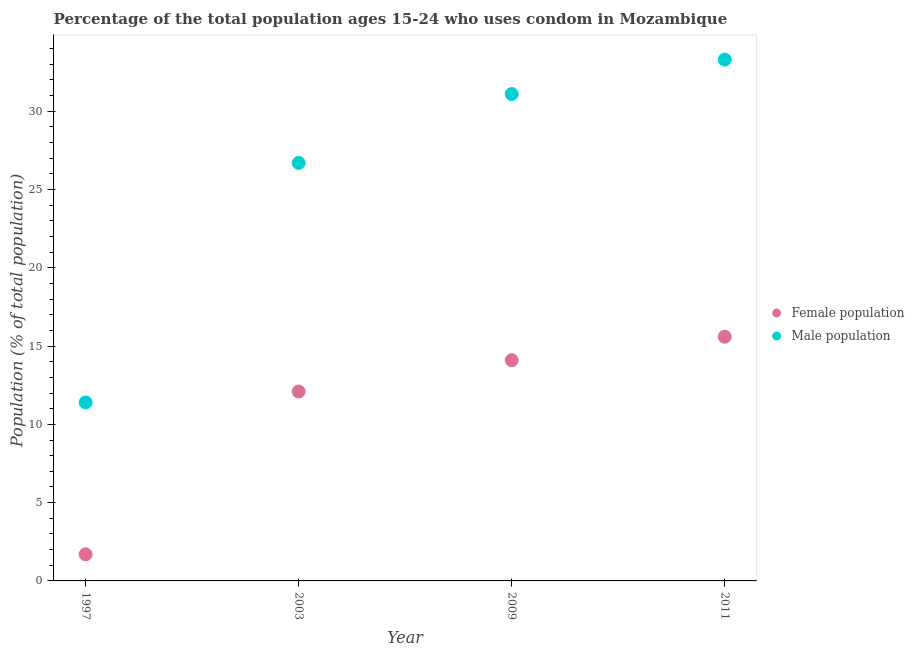What is the male population in 2003?
Give a very brief answer. 26.7. Across all years, what is the maximum male population?
Make the answer very short. 33.3. In which year was the female population maximum?
Provide a succinct answer. 2011. What is the total male population in the graph?
Your answer should be very brief. 102.5. What is the difference between the female population in 2003 and that in 2009?
Offer a very short reply. -2. What is the difference between the female population in 2011 and the male population in 2009?
Provide a succinct answer. -15.5. What is the average male population per year?
Keep it short and to the point. 25.62. In how many years, is the female population greater than 10 %?
Offer a terse response. 3. What is the ratio of the female population in 2003 to that in 2009?
Give a very brief answer. 0.86. Is the difference between the male population in 2003 and 2009 greater than the difference between the female population in 2003 and 2009?
Your answer should be compact. No. What is the difference between the highest and the second highest male population?
Offer a terse response. 2.2. What is the difference between the highest and the lowest male population?
Provide a succinct answer. 21.9. Is the sum of the male population in 1997 and 2011 greater than the maximum female population across all years?
Keep it short and to the point. Yes. How many dotlines are there?
Give a very brief answer. 2. How many years are there in the graph?
Keep it short and to the point. 4. What is the difference between two consecutive major ticks on the Y-axis?
Offer a terse response. 5. Are the values on the major ticks of Y-axis written in scientific E-notation?
Offer a terse response. No. Does the graph contain any zero values?
Provide a short and direct response. No. Does the graph contain grids?
Provide a short and direct response. No. How are the legend labels stacked?
Provide a succinct answer. Vertical. What is the title of the graph?
Ensure brevity in your answer.  Percentage of the total population ages 15-24 who uses condom in Mozambique. What is the label or title of the X-axis?
Keep it short and to the point. Year. What is the label or title of the Y-axis?
Make the answer very short. Population (% of total population) . What is the Population (% of total population)  in Female population in 2003?
Keep it short and to the point. 12.1. What is the Population (% of total population)  in Male population in 2003?
Ensure brevity in your answer.  26.7. What is the Population (% of total population)  of Female population in 2009?
Your answer should be compact. 14.1. What is the Population (% of total population)  of Male population in 2009?
Ensure brevity in your answer.  31.1. What is the Population (% of total population)  of Female population in 2011?
Keep it short and to the point. 15.6. What is the Population (% of total population)  of Male population in 2011?
Your answer should be compact. 33.3. Across all years, what is the maximum Population (% of total population)  of Male population?
Offer a terse response. 33.3. Across all years, what is the minimum Population (% of total population)  of Female population?
Your response must be concise. 1.7. Across all years, what is the minimum Population (% of total population)  of Male population?
Offer a terse response. 11.4. What is the total Population (% of total population)  of Female population in the graph?
Ensure brevity in your answer.  43.5. What is the total Population (% of total population)  of Male population in the graph?
Your answer should be compact. 102.5. What is the difference between the Population (% of total population)  of Male population in 1997 and that in 2003?
Provide a short and direct response. -15.3. What is the difference between the Population (% of total population)  of Male population in 1997 and that in 2009?
Ensure brevity in your answer.  -19.7. What is the difference between the Population (% of total population)  of Male population in 1997 and that in 2011?
Offer a very short reply. -21.9. What is the difference between the Population (% of total population)  of Male population in 2003 and that in 2009?
Offer a very short reply. -4.4. What is the difference between the Population (% of total population)  in Female population in 1997 and the Population (% of total population)  in Male population in 2003?
Your answer should be very brief. -25. What is the difference between the Population (% of total population)  in Female population in 1997 and the Population (% of total population)  in Male population in 2009?
Keep it short and to the point. -29.4. What is the difference between the Population (% of total population)  of Female population in 1997 and the Population (% of total population)  of Male population in 2011?
Provide a short and direct response. -31.6. What is the difference between the Population (% of total population)  in Female population in 2003 and the Population (% of total population)  in Male population in 2009?
Offer a terse response. -19. What is the difference between the Population (% of total population)  in Female population in 2003 and the Population (% of total population)  in Male population in 2011?
Make the answer very short. -21.2. What is the difference between the Population (% of total population)  in Female population in 2009 and the Population (% of total population)  in Male population in 2011?
Give a very brief answer. -19.2. What is the average Population (% of total population)  of Female population per year?
Give a very brief answer. 10.88. What is the average Population (% of total population)  of Male population per year?
Your answer should be compact. 25.62. In the year 2003, what is the difference between the Population (% of total population)  in Female population and Population (% of total population)  in Male population?
Your response must be concise. -14.6. In the year 2009, what is the difference between the Population (% of total population)  in Female population and Population (% of total population)  in Male population?
Provide a succinct answer. -17. In the year 2011, what is the difference between the Population (% of total population)  in Female population and Population (% of total population)  in Male population?
Make the answer very short. -17.7. What is the ratio of the Population (% of total population)  of Female population in 1997 to that in 2003?
Your answer should be very brief. 0.14. What is the ratio of the Population (% of total population)  of Male population in 1997 to that in 2003?
Make the answer very short. 0.43. What is the ratio of the Population (% of total population)  of Female population in 1997 to that in 2009?
Your answer should be compact. 0.12. What is the ratio of the Population (% of total population)  in Male population in 1997 to that in 2009?
Offer a terse response. 0.37. What is the ratio of the Population (% of total population)  in Female population in 1997 to that in 2011?
Offer a very short reply. 0.11. What is the ratio of the Population (% of total population)  in Male population in 1997 to that in 2011?
Your answer should be very brief. 0.34. What is the ratio of the Population (% of total population)  in Female population in 2003 to that in 2009?
Your answer should be compact. 0.86. What is the ratio of the Population (% of total population)  in Male population in 2003 to that in 2009?
Provide a short and direct response. 0.86. What is the ratio of the Population (% of total population)  of Female population in 2003 to that in 2011?
Offer a very short reply. 0.78. What is the ratio of the Population (% of total population)  in Male population in 2003 to that in 2011?
Your answer should be very brief. 0.8. What is the ratio of the Population (% of total population)  of Female population in 2009 to that in 2011?
Provide a succinct answer. 0.9. What is the ratio of the Population (% of total population)  of Male population in 2009 to that in 2011?
Make the answer very short. 0.93. What is the difference between the highest and the second highest Population (% of total population)  in Male population?
Your answer should be compact. 2.2. What is the difference between the highest and the lowest Population (% of total population)  in Female population?
Make the answer very short. 13.9. What is the difference between the highest and the lowest Population (% of total population)  in Male population?
Your response must be concise. 21.9. 